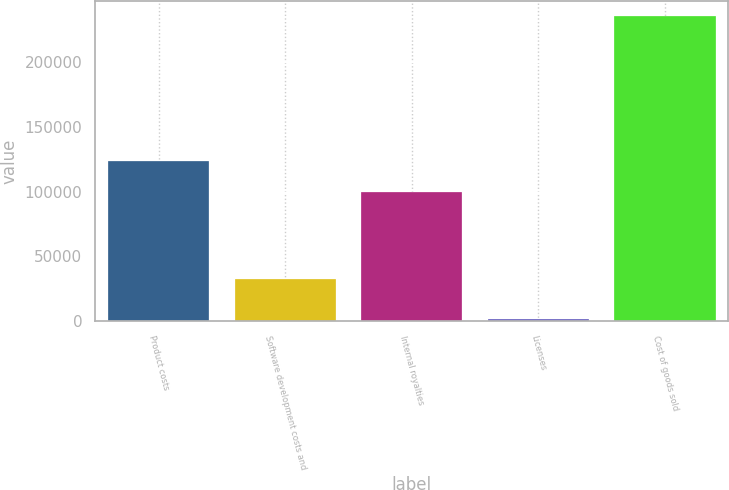Convert chart. <chart><loc_0><loc_0><loc_500><loc_500><bar_chart><fcel>Product costs<fcel>Software development costs and<fcel>Internal royalties<fcel>Licenses<fcel>Cost of goods sold<nl><fcel>123207<fcel>32913<fcel>99880<fcel>2023<fcel>235289<nl></chart> 